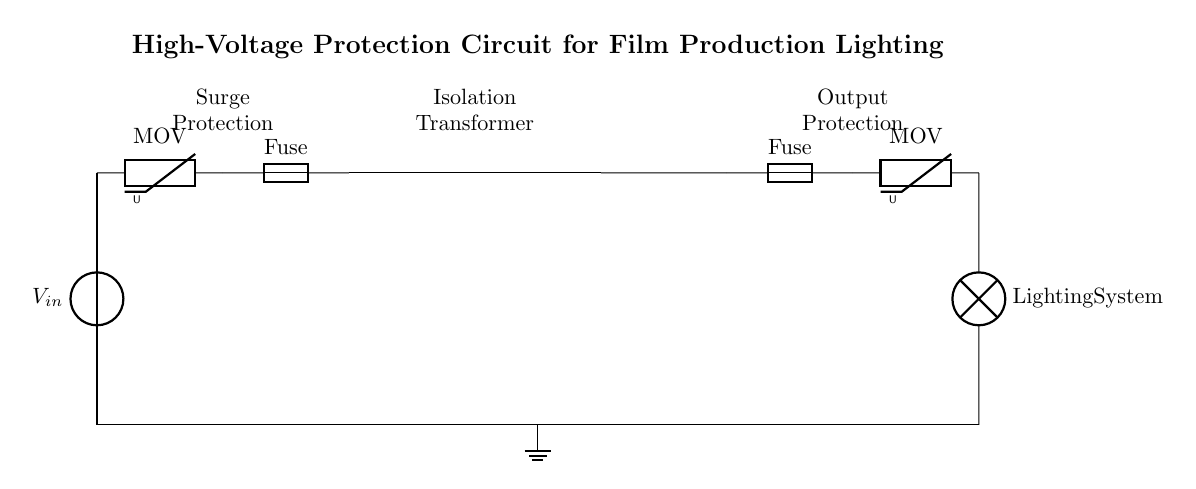What is the input voltage in this circuit? The input voltage, represented as V_in, is the voltage supplied to the circuit from the source at the leftmost part of the diagram.
Answer: V_in What does MOV stand for? The acronym MOV stands for Metal Oxide Varistor, which is used for surge protection in this circuit.
Answer: Metal Oxide Varistor How many fuses are present in the circuit? There are two fuses in the circuit diagram: one before the isolation transformer and one after the output protection stage.
Answer: 2 What is the function of the isolation transformer? The isolation transformer serves to separate the lighting system from the power source, providing electrical isolation and safety for the load.
Answer: Electrical isolation What is the purpose of the surge protection section? The surge protection section, which includes a varistor and a fuse, is designed to protect the circuit from voltage spikes that could damage the connected equipment.
Answer: Protect from voltage spikes Why are there ground connections in the circuit? Ground connections provide a reference point for voltage levels, ensure safety by preventing electrical shock, and protect the equipment in case of a fault.
Answer: Safety and reference 